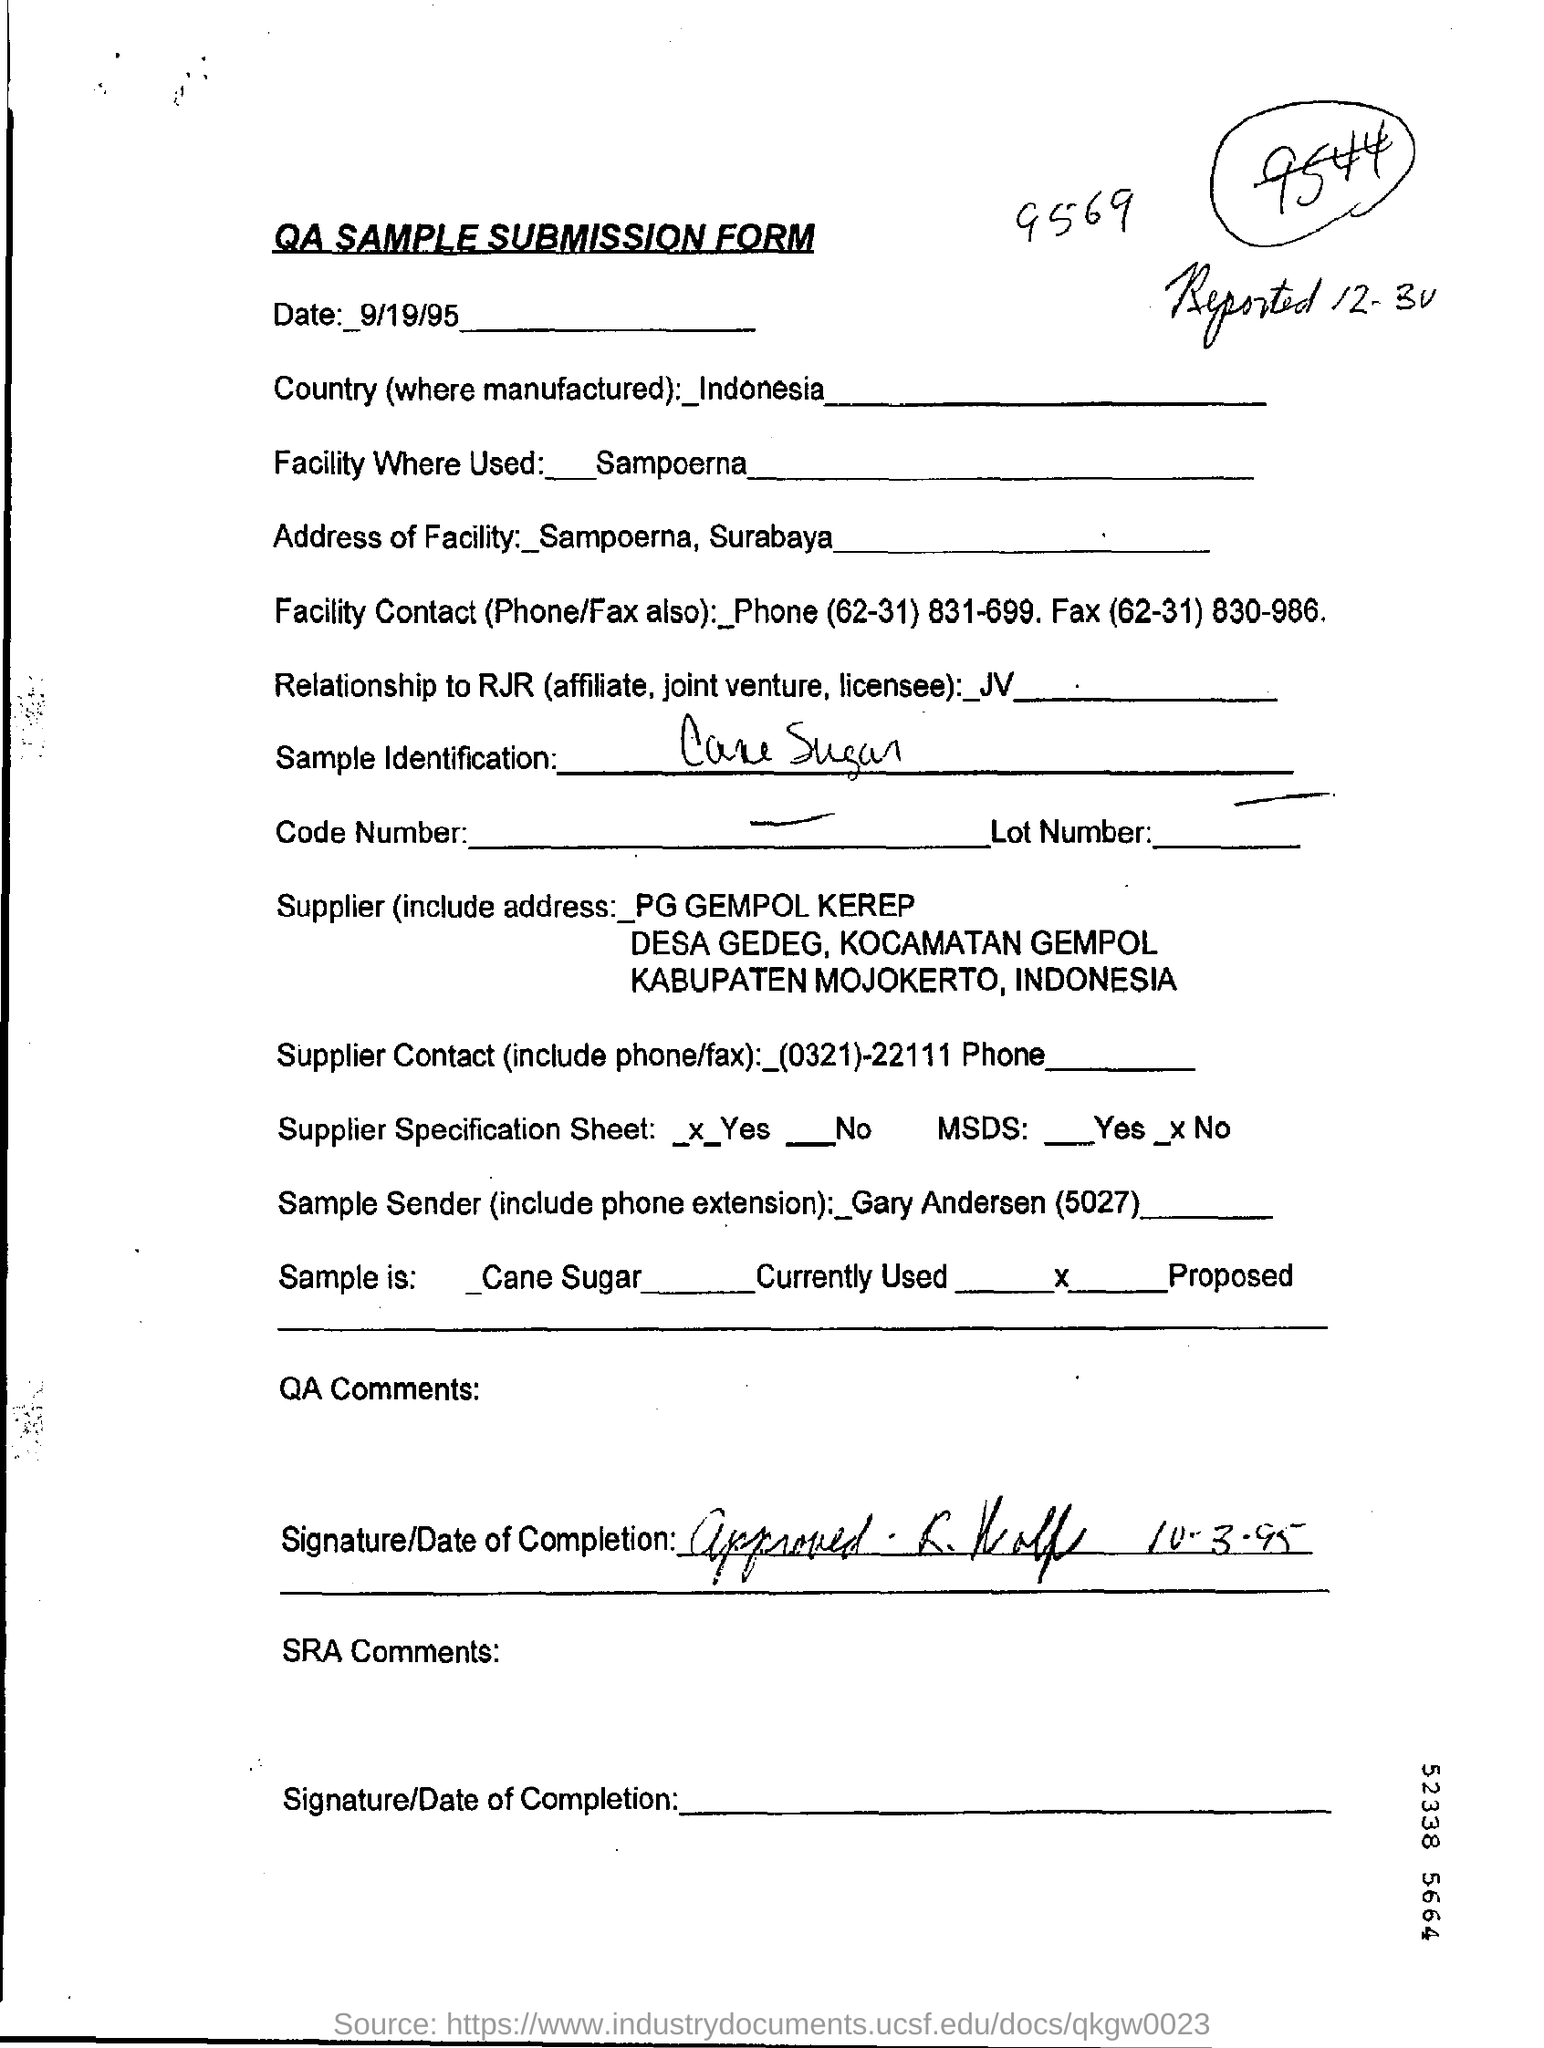What is the Title of the document ?
Provide a short and direct response. QA Sample submission form. What is the date mentioned in the top of the document ?
Your answer should be very brief. 9/19/95. What is the Country Name ?
Offer a very short reply. Indonesia. What is mentioned in the Facility Where Used Field ?
Offer a very short reply. Sampoerna. 